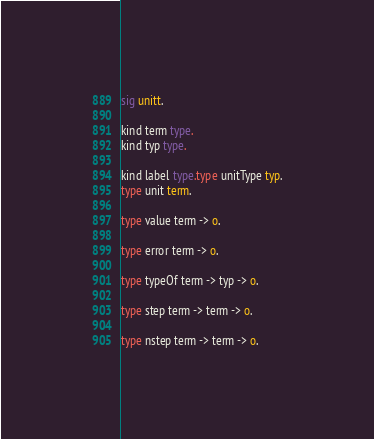Convert code to text. <code><loc_0><loc_0><loc_500><loc_500><_SML_>sig unitt.

kind term type.
kind typ type.

kind label type.type unitType typ.
type unit term.

type value term -> o.

type error term -> o.

type typeOf term -> typ -> o.

type step term -> term -> o.

type nstep term -> term -> o.

</code> 